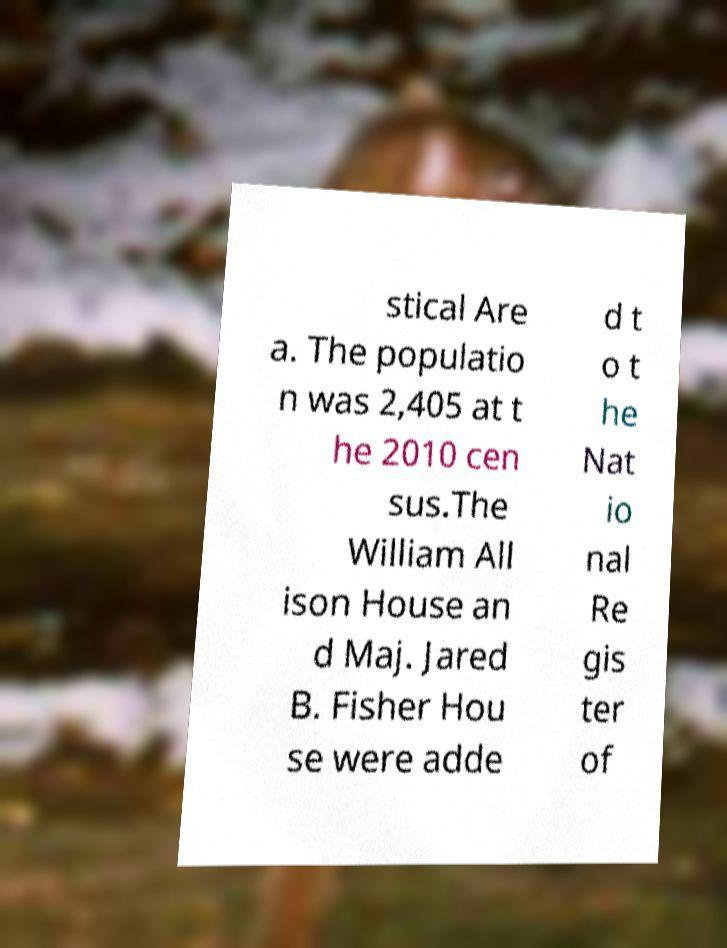What messages or text are displayed in this image? I need them in a readable, typed format. stical Are a. The populatio n was 2,405 at t he 2010 cen sus.The William All ison House an d Maj. Jared B. Fisher Hou se were adde d t o t he Nat io nal Re gis ter of 